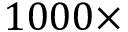<formula> <loc_0><loc_0><loc_500><loc_500>1 0 0 0 \times</formula> 